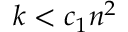<formula> <loc_0><loc_0><loc_500><loc_500>k < c _ { 1 } n ^ { 2 }</formula> 